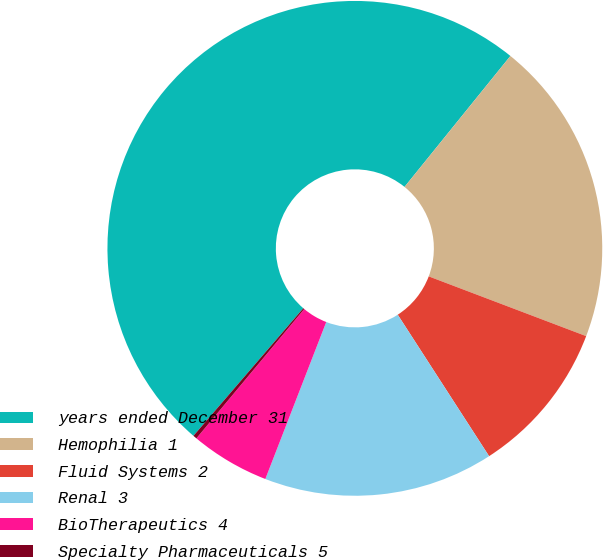Convert chart to OTSL. <chart><loc_0><loc_0><loc_500><loc_500><pie_chart><fcel>years ended December 31<fcel>Hemophilia 1<fcel>Fluid Systems 2<fcel>Renal 3<fcel>BioTherapeutics 4<fcel>Specialty Pharmaceuticals 5<nl><fcel>49.51%<fcel>19.95%<fcel>10.1%<fcel>15.02%<fcel>5.17%<fcel>0.25%<nl></chart> 